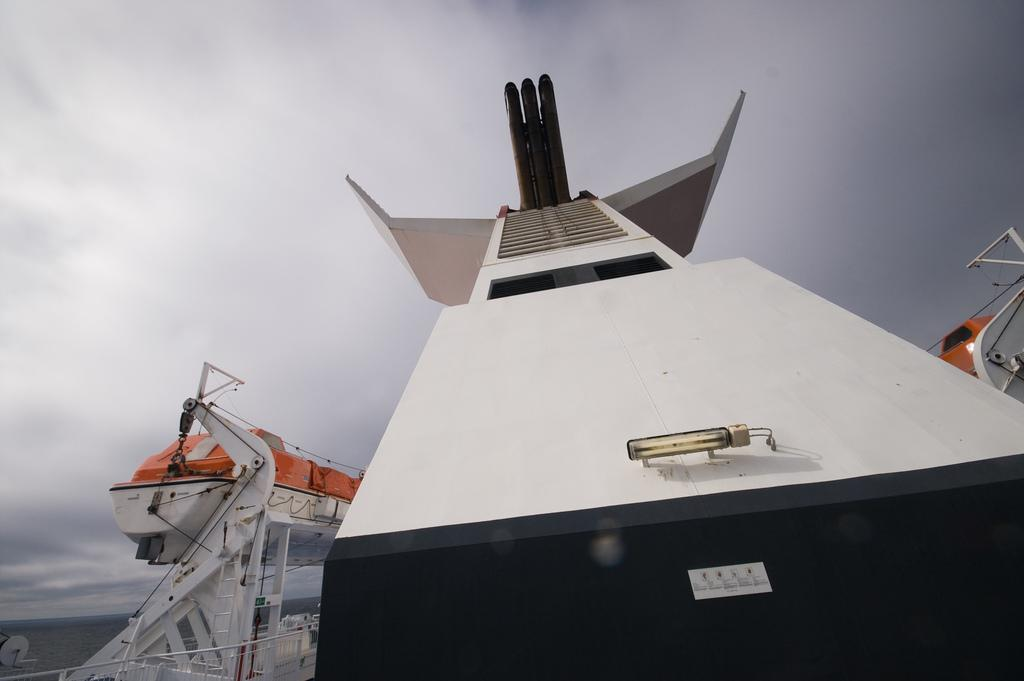What is the main subject in the foreground of the image? There is a ship in the foreground of the image. What can be seen in the background of the image? There is water and the sky visible in the background of the image. How many stitches are visible on the ship's sails in the image? There are no visible stitches on the ship's sails in the image, as the image does not provide a close-up view of the sails. 